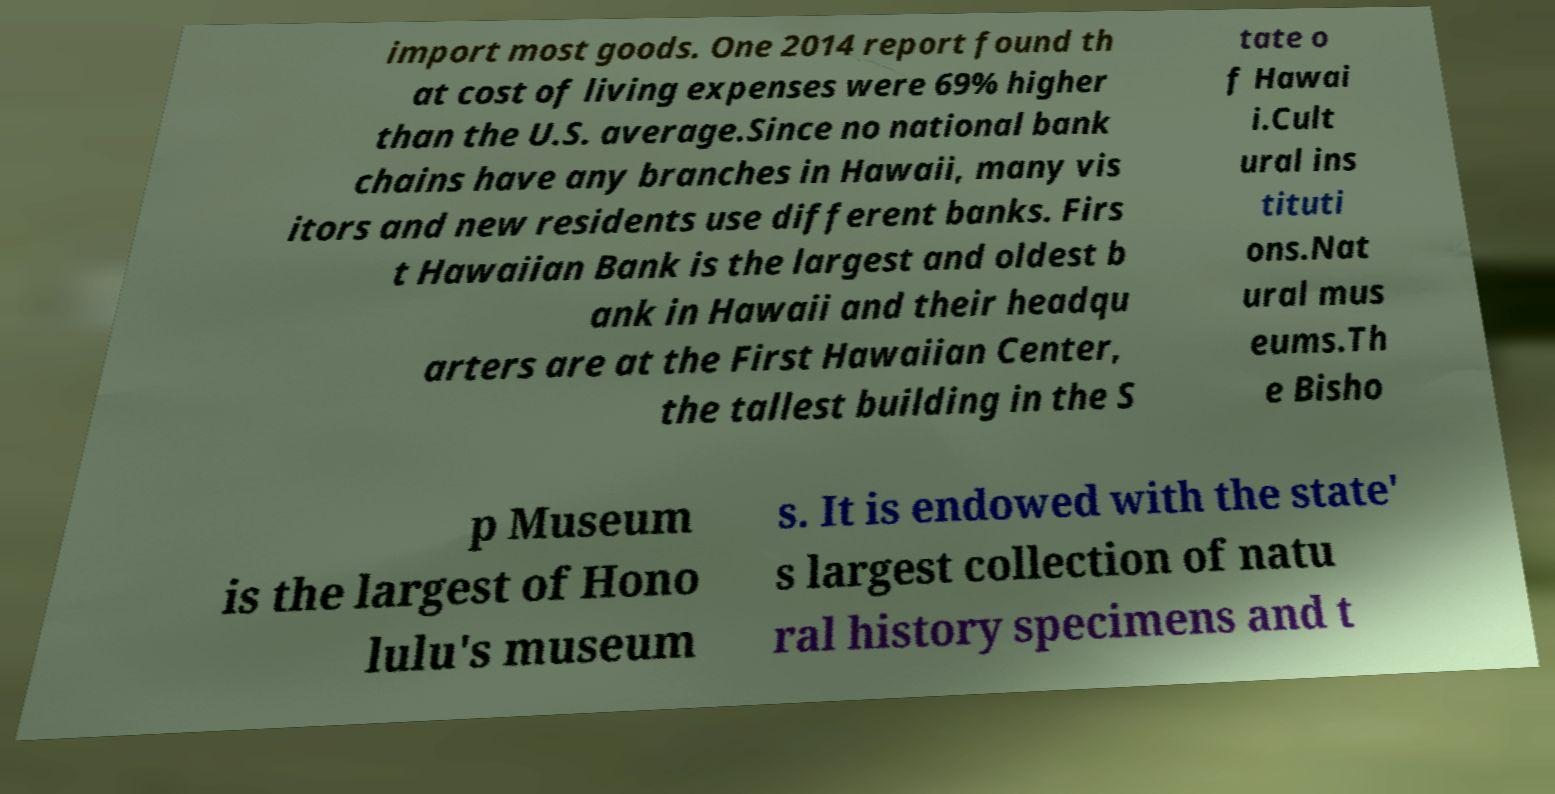For documentation purposes, I need the text within this image transcribed. Could you provide that? import most goods. One 2014 report found th at cost of living expenses were 69% higher than the U.S. average.Since no national bank chains have any branches in Hawaii, many vis itors and new residents use different banks. Firs t Hawaiian Bank is the largest and oldest b ank in Hawaii and their headqu arters are at the First Hawaiian Center, the tallest building in the S tate o f Hawai i.Cult ural ins tituti ons.Nat ural mus eums.Th e Bisho p Museum is the largest of Hono lulu's museum s. It is endowed with the state' s largest collection of natu ral history specimens and t 